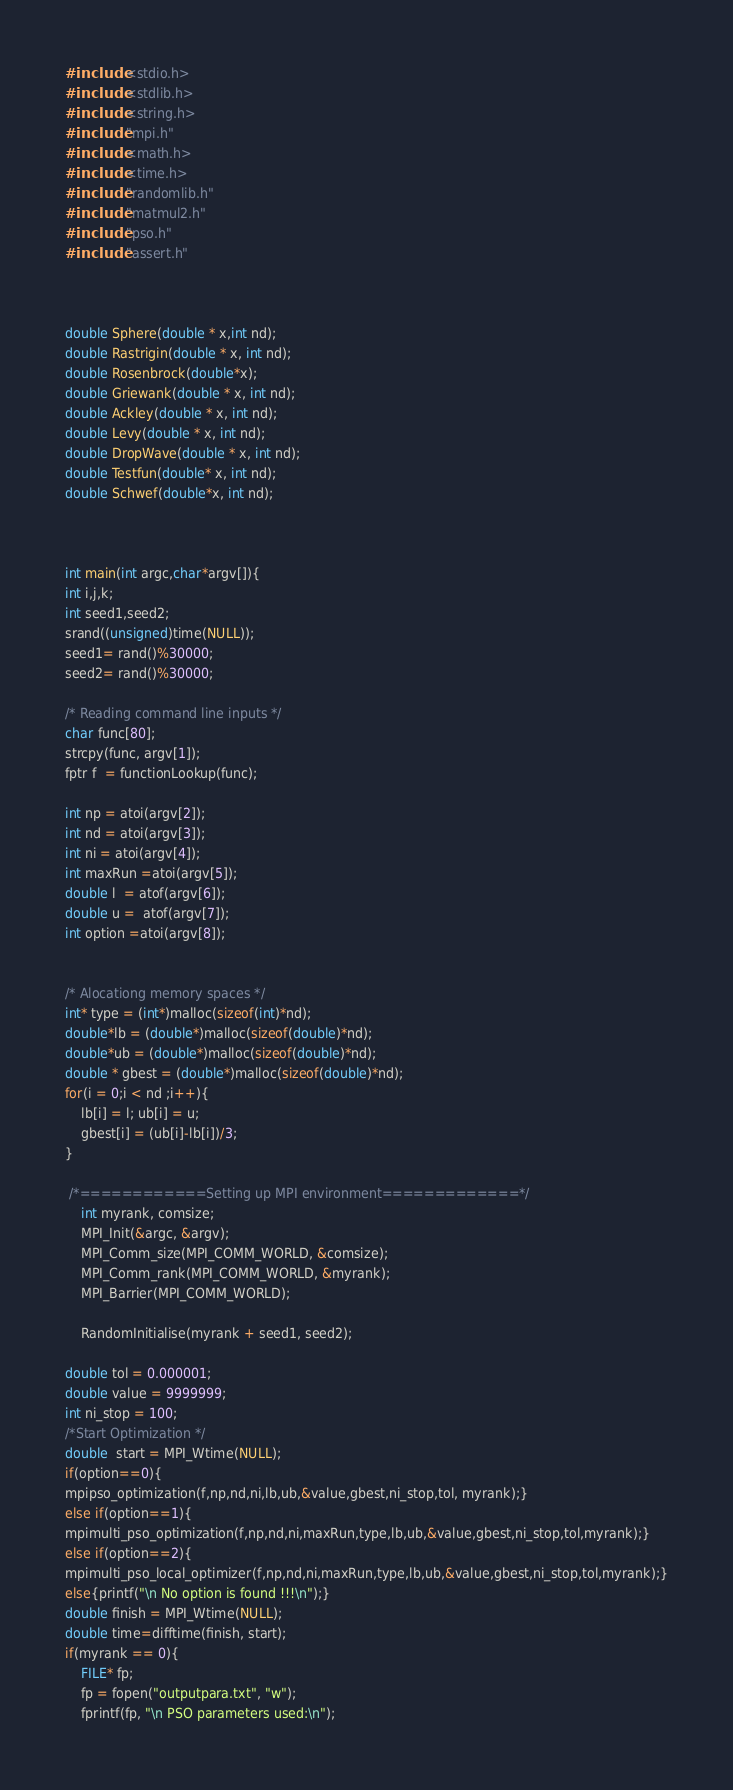<code> <loc_0><loc_0><loc_500><loc_500><_C_>#include <stdio.h>
#include <stdlib.h>
#include <string.h>
#include "mpi.h"
#include <math.h>
#include <time.h>
#include "randomlib.h"
#include "matmul2.h"
#include "pso.h"
#include "assert.h"



double Sphere(double * x,int nd);
double Rastrigin(double * x, int nd);
double Rosenbrock(double*x);
double Griewank(double * x, int nd);
double Ackley(double * x, int nd);
double Levy(double * x, int nd);
double DropWave(double * x, int nd);
double Testfun(double* x, int nd);
double Schwef(double*x, int nd);



int main(int argc,char*argv[]){
int i,j,k;
int seed1,seed2;
srand((unsigned)time(NULL));
seed1= rand()%30000;
seed2= rand()%30000;

/* Reading command line inputs */
char func[80];
strcpy(func, argv[1]);
fptr f  = functionLookup(func);

int np = atoi(argv[2]);
int nd = atoi(argv[3]);
int ni = atoi(argv[4]);
int maxRun =atoi(argv[5]);
double l  = atof(argv[6]);
double u =  atof(argv[7]);
int option =atoi(argv[8]);


/* Alocationg memory spaces */
int* type = (int*)malloc(sizeof(int)*nd);
double*lb = (double*)malloc(sizeof(double)*nd);
double*ub = (double*)malloc(sizeof(double)*nd);
double * gbest = (double*)malloc(sizeof(double)*nd);
for(i = 0;i < nd ;i++){
    lb[i] = l; ub[i] = u;
    gbest[i] = (ub[i]-lb[i])/3;
}

 /*============Setting up MPI environment=============*/
    int myrank, comsize;
    MPI_Init(&argc, &argv);
    MPI_Comm_size(MPI_COMM_WORLD, &comsize);
    MPI_Comm_rank(MPI_COMM_WORLD, &myrank);
    MPI_Barrier(MPI_COMM_WORLD);

    RandomInitialise(myrank + seed1, seed2);

double tol = 0.000001;
double value = 9999999;
int ni_stop = 100;
/*Start Optimization */
double  start = MPI_Wtime(NULL);
if(option==0){
mpipso_optimization(f,np,nd,ni,lb,ub,&value,gbest,ni_stop,tol, myrank);}
else if(option==1){
mpimulti_pso_optimization(f,np,nd,ni,maxRun,type,lb,ub,&value,gbest,ni_stop,tol,myrank);}
else if(option==2){
mpimulti_pso_local_optimizer(f,np,nd,ni,maxRun,type,lb,ub,&value,gbest,ni_stop,tol,myrank);}
else{printf("\n No option is found !!!\n");}
double finish = MPI_Wtime(NULL);
double time=difftime(finish, start);
if(myrank == 0){
	FILE* fp;
	fp = fopen("outputpara.txt", "w");
	fprintf(fp, "\n PSO parameters used:\n");</code> 